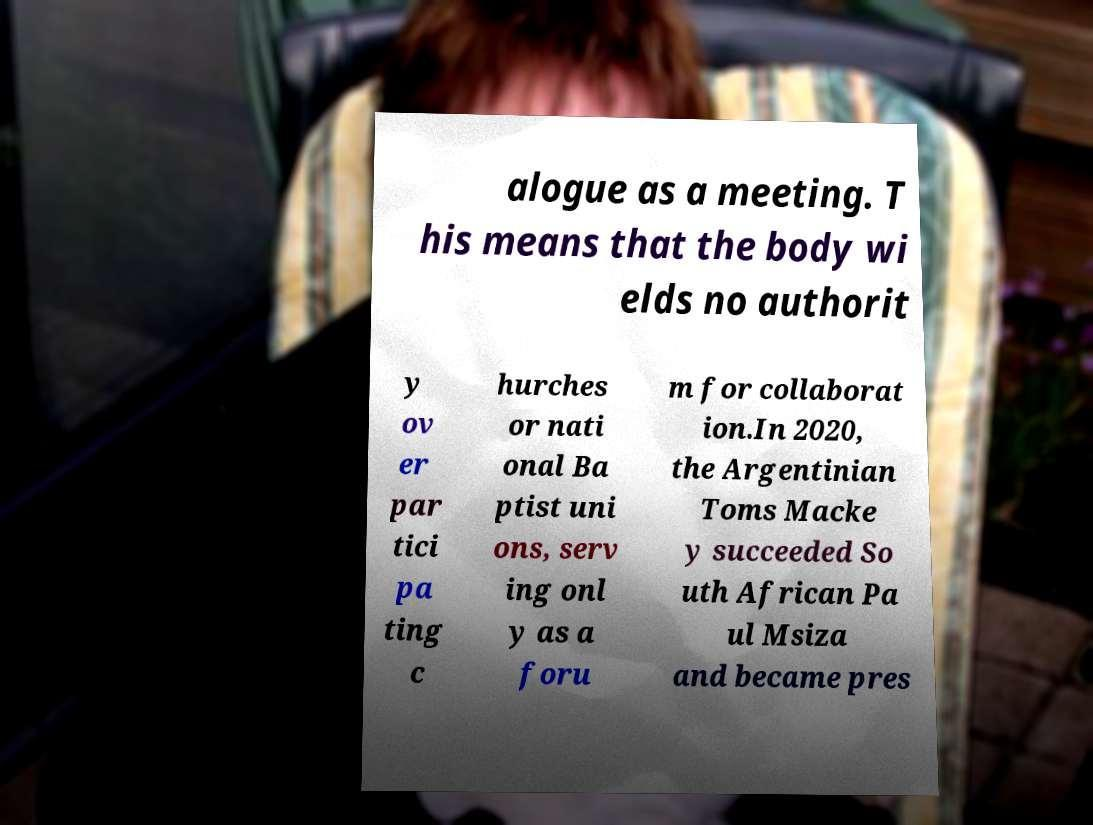What messages or text are displayed in this image? I need them in a readable, typed format. alogue as a meeting. T his means that the body wi elds no authorit y ov er par tici pa ting c hurches or nati onal Ba ptist uni ons, serv ing onl y as a foru m for collaborat ion.In 2020, the Argentinian Toms Macke y succeeded So uth African Pa ul Msiza and became pres 